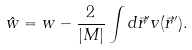<formula> <loc_0><loc_0><loc_500><loc_500>\hat { w } = w - \frac { 2 } { | M | } \int d \vec { r } ^ { \prime } v ( \vec { r } ^ { \prime } ) .</formula> 